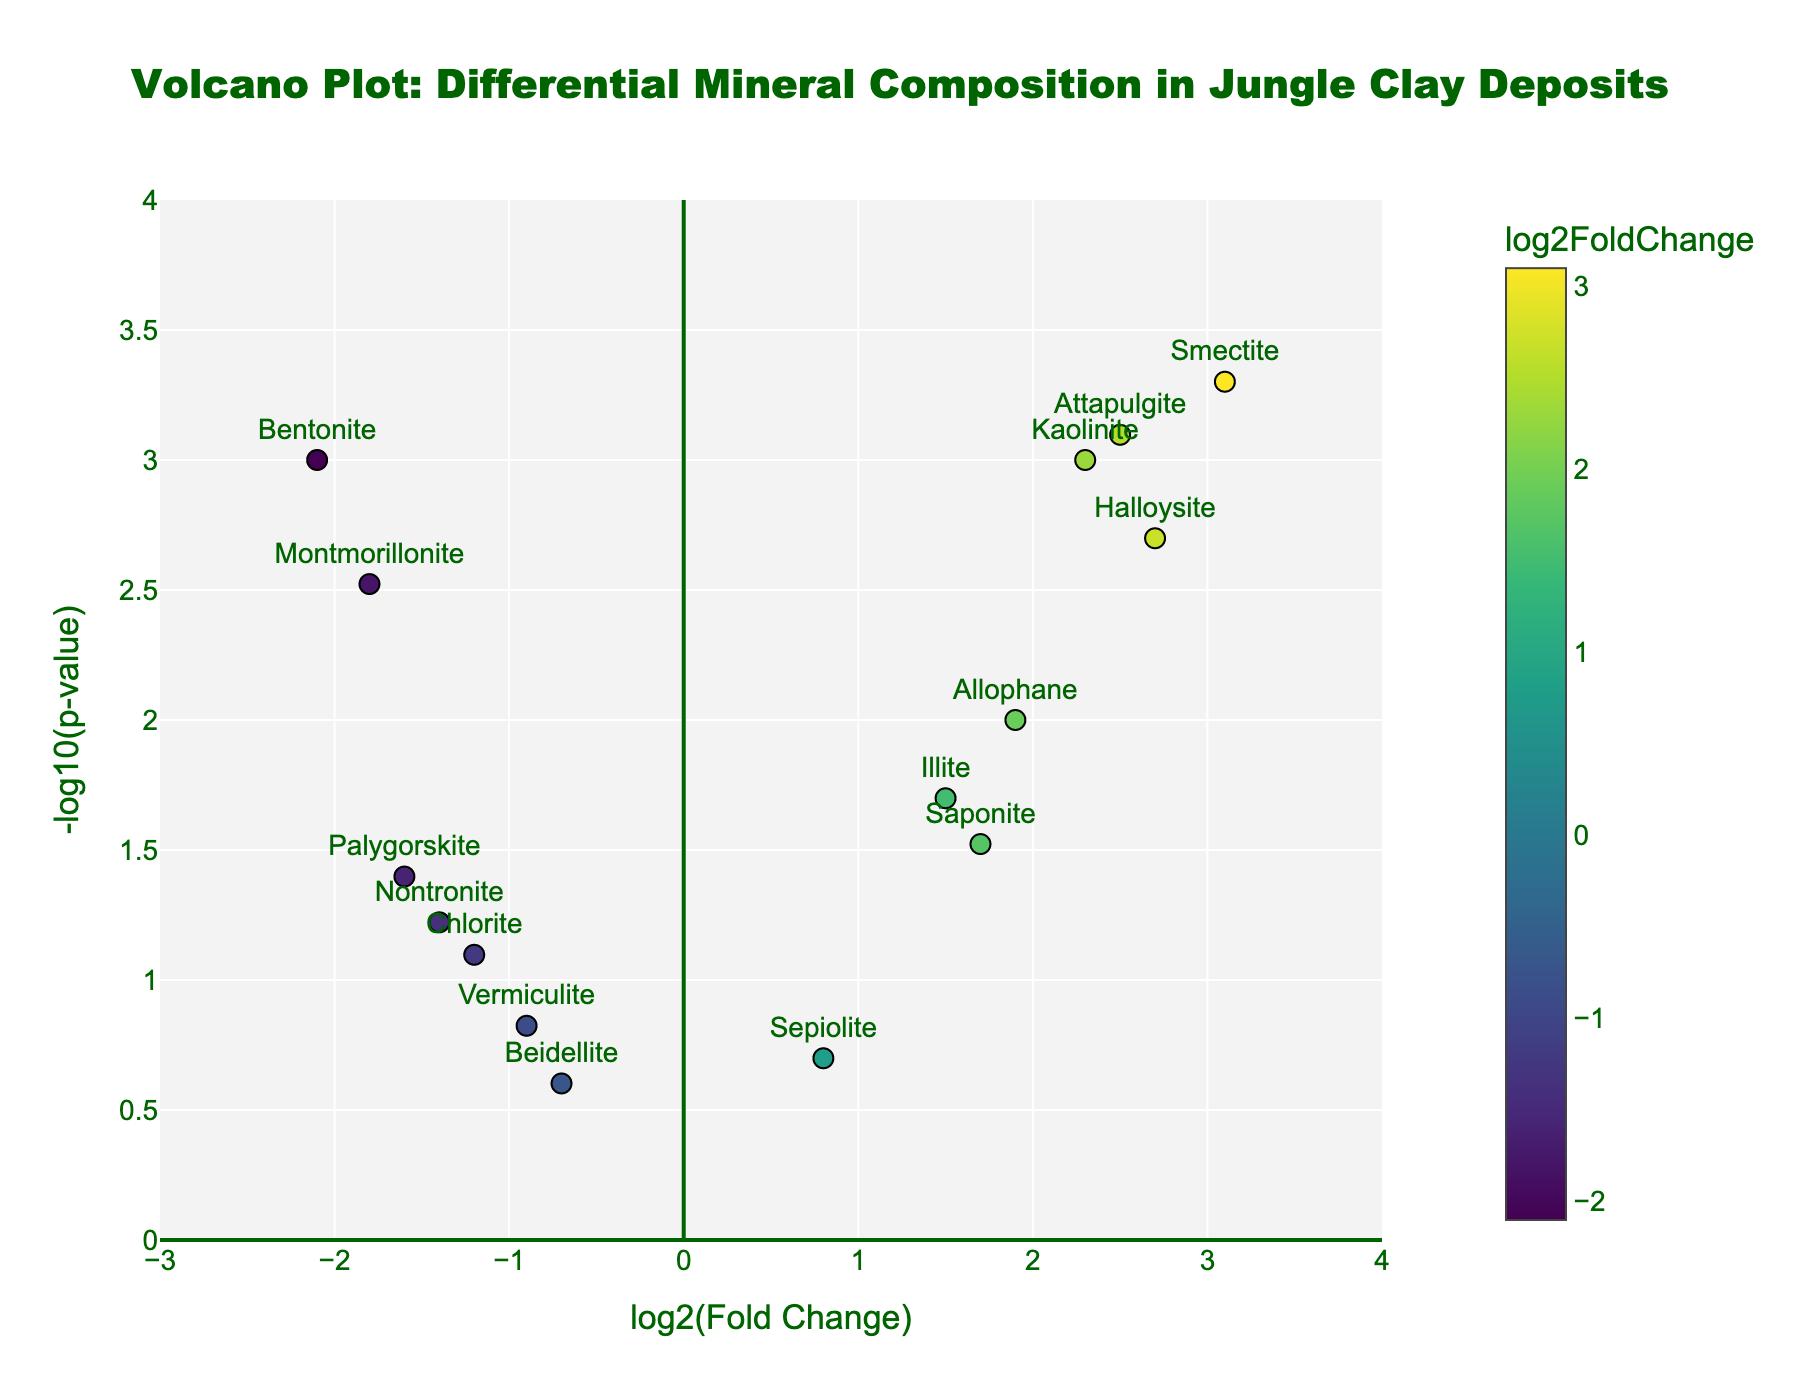What is the title of the plot? The title is usually displayed at the top center of the plot. In this case, it is clearly shown as "Volcano Plot: Differential Mineral Composition in Jungle Clay Deposits".
Answer: Volcano Plot: Differential Mineral Composition in Jungle Clay Deposits How many minerals in the plot have a log2FoldChange greater than 2? Look at the x-axis values and count the number of data points that are positioned to the right of the value 2 on the x-axis. The minerals are Kaolinite, Smectite, Halloysite, and Attapulgite.
Answer: 4 Which mineral has the highest -log10(p-value)? To find the mineral with the highest -log10(p-value), look at the y-axis and identify the data point that is at the topmost position. Smectite is at the highest position.
Answer: Smectite Which mineral has the lowest log2FoldChange? To find the mineral with the lowest log2FoldChange, look at the x-axis and identify the data point that is positioned farthest to the left. Bentonite is the mineral positioned farthest to the left.
Answer: Bentonite What is the range of the x-axis (log2FoldChange)? The range of the x-axis is shown by the numbers at the ends of the x-axis line. The x-axis ranges from -3 to 4.
Answer: -3 to 4 Which minerals are located in the top-right quadrant of the plot? The top-right quadrant includes minerals with high log2FoldChange and low p-values (-log10(p-value) is high). The minerals in this quadrant are Kaolinite, Smectite, Halloysite, Allophane, Attapulgite, and Saponite.
Answer: Kaolinite, Smectite, Halloysite, Allophane, Attapulgite, Saponite Compare the p-values of Kaolinite and Montmorillonite. Which one is more statistically significant? To compare the p-values, check the vertical position (y-axis value) of Kaolinite and Montmorillonite. Higher -log10(p-value) means a more significant result. Kaolinite (y > 3) is more statistically significant than Montmorillonite (y ≈ 2.5).
Answer: Kaolinite What color represents the highest log2FoldChange on the color scale? Examine the color scale shown in the plot and identify the color corresponding to the highest log2FoldChange value. The highest log2FoldChange value is near 4, which is represented by the color at the top of the Viridis color scale.
Answer: Dark yellow Which mineral appears closest to the bottom-left corner of the plot? To find the mineral closest to the bottom-left corner, look for the data point with the lowest values of both x (log2FoldChange) and y (-log10(p-value)). Beidellite is closest to this corner.
Answer: Beidellite 